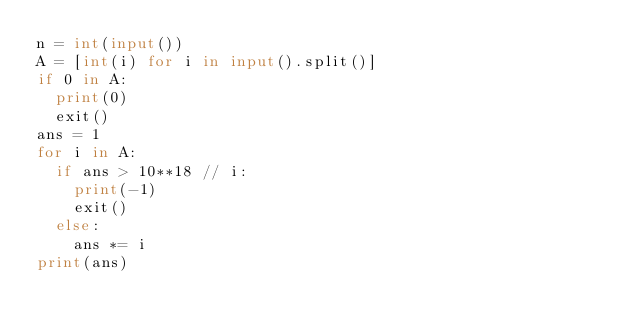<code> <loc_0><loc_0><loc_500><loc_500><_Python_>n = int(input())
A = [int(i) for i in input().split()]
if 0 in A:
  print(0)
  exit()
ans = 1
for i in A:
  if ans > 10**18 // i:
    print(-1)
    exit()
  else:
    ans *= i
print(ans)</code> 